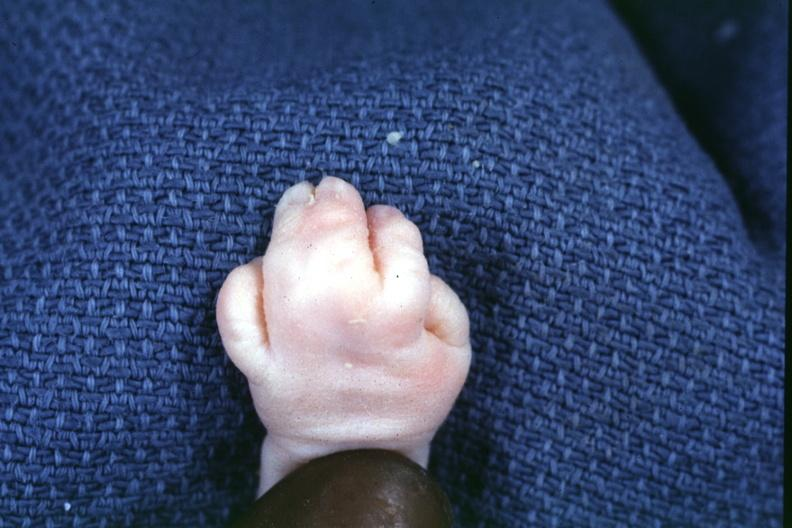what is present?
Answer the question using a single word or phrase. Syndactyly 